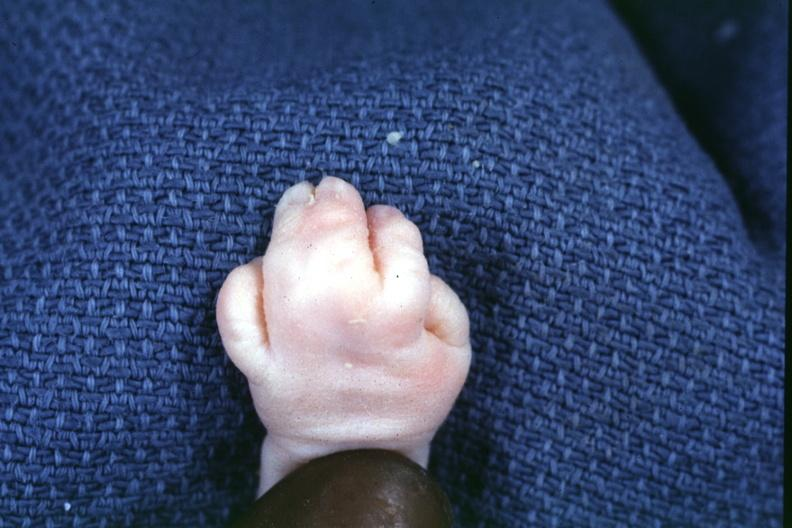what is present?
Answer the question using a single word or phrase. Syndactyly 